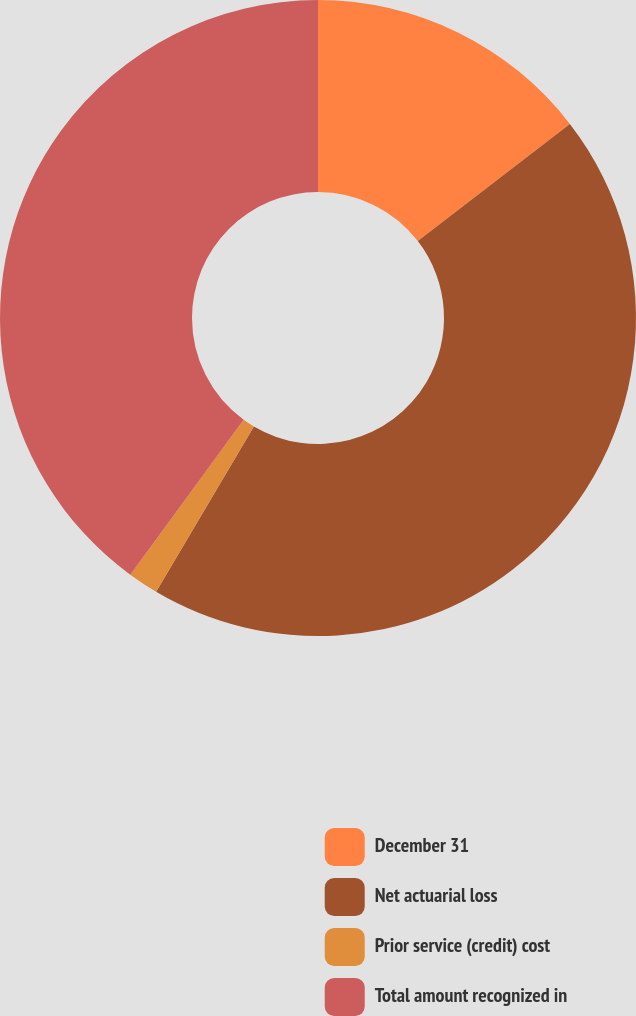Convert chart. <chart><loc_0><loc_0><loc_500><loc_500><pie_chart><fcel>December 31<fcel>Net actuarial loss<fcel>Prior service (credit) cost<fcel>Total amount recognized in<nl><fcel>14.55%<fcel>43.95%<fcel>1.55%<fcel>39.95%<nl></chart> 